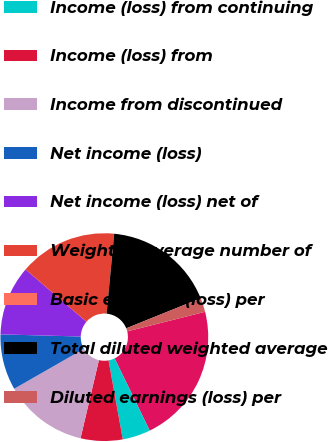<chart> <loc_0><loc_0><loc_500><loc_500><pie_chart><fcel>(in millions except per-share<fcel>Income (loss) from continuing<fcel>Income (loss) from<fcel>Income from discontinued<fcel>Net income (loss)<fcel>Net income (loss) net of<fcel>Weighted average number of<fcel>Basic earnings (loss) per<fcel>Total diluted weighted average<fcel>Diluted earnings (loss) per<nl><fcel>21.73%<fcel>4.35%<fcel>6.52%<fcel>13.04%<fcel>8.7%<fcel>10.87%<fcel>15.21%<fcel>0.01%<fcel>17.38%<fcel>2.18%<nl></chart> 